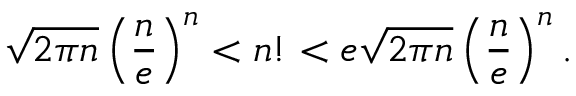Convert formula to latex. <formula><loc_0><loc_0><loc_500><loc_500>\sqrt { 2 \pi n } \left ( \frac { n } { e } \right ) ^ { n } < n ! < e \sqrt { 2 \pi n } \left ( \frac { n } { e } \right ) ^ { n } .</formula> 